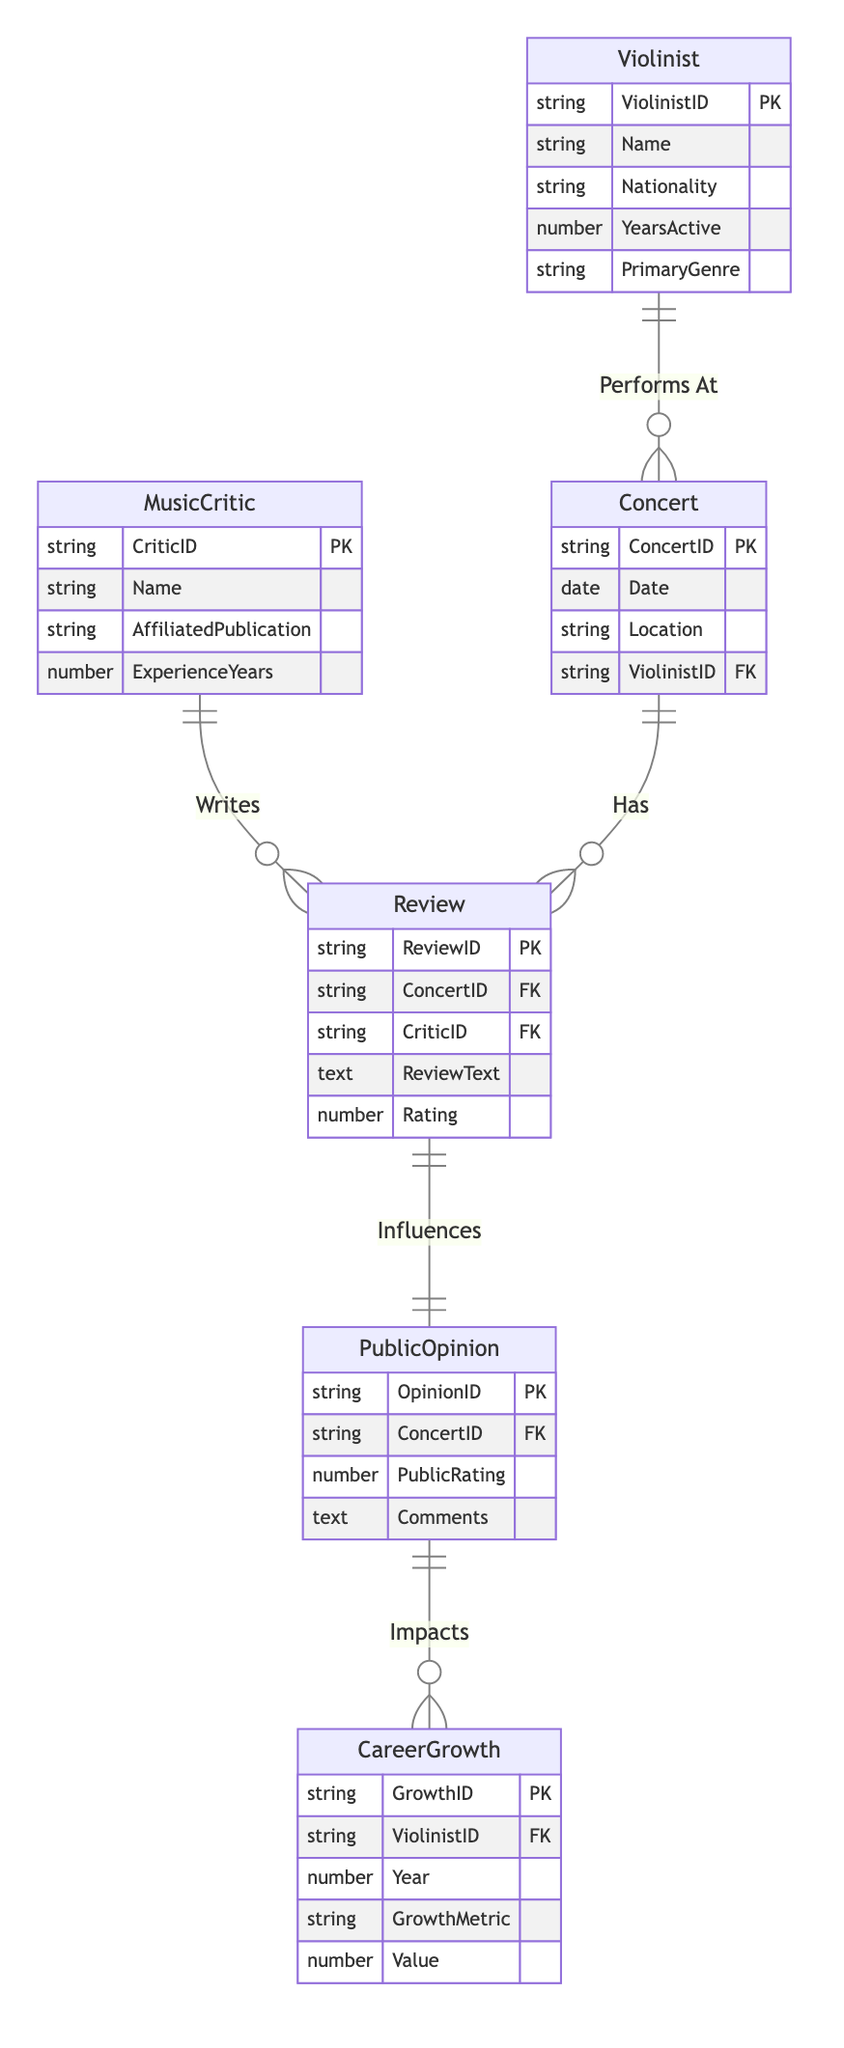What is the cardinality between Violinist and Concert? The cardinality between Violinist and Concert is one-to-many, indicating that one violinist can perform at multiple concerts.
Answer: One-to-Many How many attributes does the Review entity have? The Review entity has five attributes: ReviewID, ConcertID, CriticID, ReviewText, and Rating. By counting them, we see that the total is five.
Answer: Five Which entity is influenced by the Review? The entity that is influenced by the Review is PublicOpinion. The relationship shows that a Review directly impacts the PublicOpinion regarding a concert.
Answer: PublicOpinion What is the foreign key in the Concert entity? The foreign key in the Concert entity is ViolinistID, which links each concert to the specific violinist performing at it.
Answer: ViolinistID How many relationships are shown in this diagram? The diagram outlines five distinct relationships: PerformsAt, Writes, Has, Influences, and Impacts, which connect various entities. Counting them gives a total of five relationships.
Answer: Five Which entity does the CareerGrowth relate to directly? The CareerGrowth relates directly to Violinist through the relationship that implies that public opinion impacts the career growth of a specific violinist.
Answer: Violinist What does the Review entity hold concerning concerts? The Review entity holds concert-specific information, namely the ConcertID, which indicates which concert the review pertains to.
Answer: ConcertID How many years of experience does the MusicCritic have? The MusicCritic has attributes that include ExperienceYears. This attribute indicates the number of years the critic has been in practice, representing their expertise level.
Answer: ExperienceYears Which entity contributes to PublicOpinion in terms of concert ratings? The entity contributing to PublicOpinion through concert ratings is Review, as public opinions are influenced by the reviews written for the concerts.
Answer: Review 